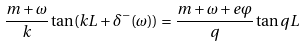<formula> <loc_0><loc_0><loc_500><loc_500>\frac { m + \omega } { k } \tan ( k L + \delta ^ { - } ( \omega ) ) = \frac { m + \omega + e \varphi } { q } \tan q L</formula> 